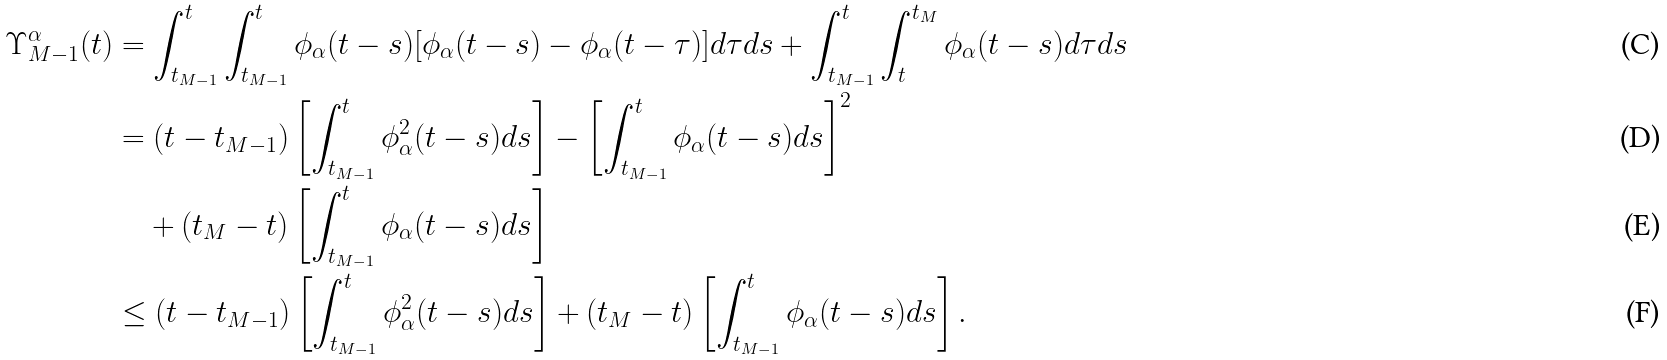Convert formula to latex. <formula><loc_0><loc_0><loc_500><loc_500>\Upsilon _ { M - 1 } ^ { \alpha } ( t ) & = \int _ { t _ { M - 1 } } ^ { t } \int _ { t _ { M - 1 } } ^ { t } \phi _ { \alpha } ( t - s ) [ \phi _ { \alpha } ( t - s ) - \phi _ { \alpha } ( t - \tau ) ] d \tau d s + \int _ { t _ { M - 1 } } ^ { t } \int _ { t } ^ { t _ { M } } \phi _ { \alpha } ( t - s ) d \tau d s \\ & = ( t - t _ { M - 1 } ) \left [ \int _ { t _ { M - 1 } } ^ { t } \phi ^ { 2 } _ { \alpha } ( t - s ) d s \right ] - \left [ \int _ { t _ { M - 1 } } ^ { t } \phi _ { \alpha } ( t - s ) d s \right ] ^ { 2 } \\ & \quad + ( t _ { M } - t ) \left [ \int _ { t _ { M - 1 } } ^ { t } \phi _ { \alpha } ( t - s ) d s \right ] \\ & \leq ( t - t _ { M - 1 } ) \left [ \int _ { t _ { M - 1 } } ^ { t } \phi ^ { 2 } _ { \alpha } ( t - s ) d s \right ] + ( t _ { M } - t ) \left [ \int _ { t _ { M - 1 } } ^ { t } \phi _ { \alpha } ( t - s ) d s \right ] .</formula> 